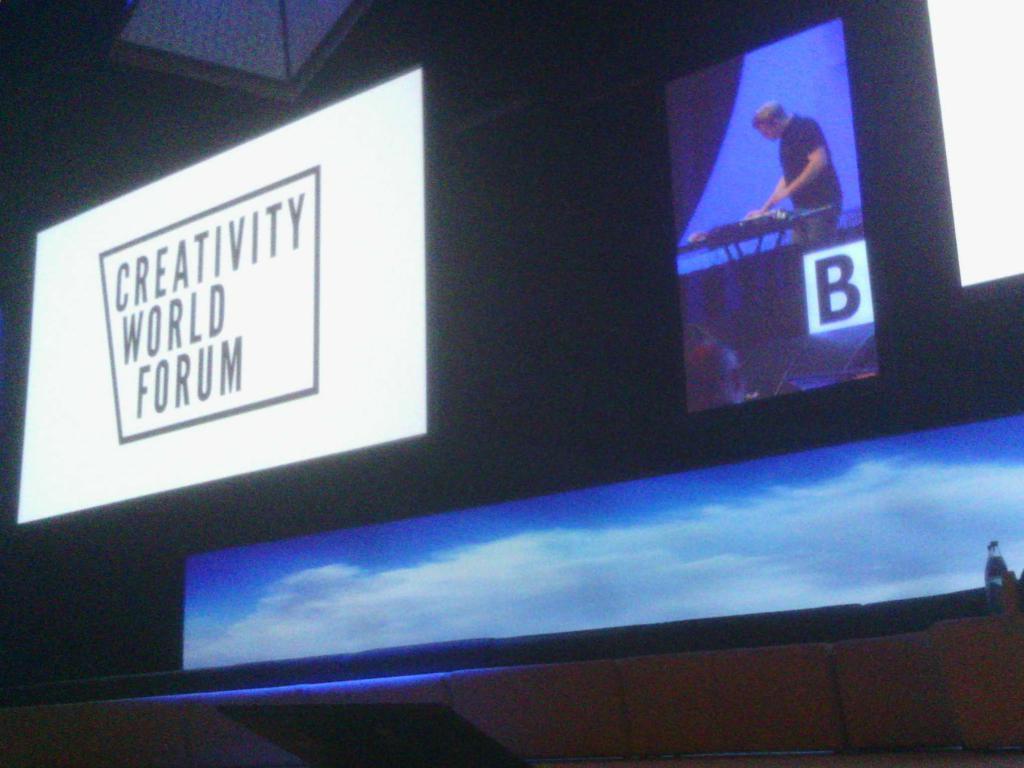Describe this image in one or two sentences. At the bottom of the picture, we see the sky and the clouds. On the left corner of the picture, we see a white board with some text written on it. In the middle of the picture, the man in black T-shirt is standing in front of the table. In the background, it is black in color. 